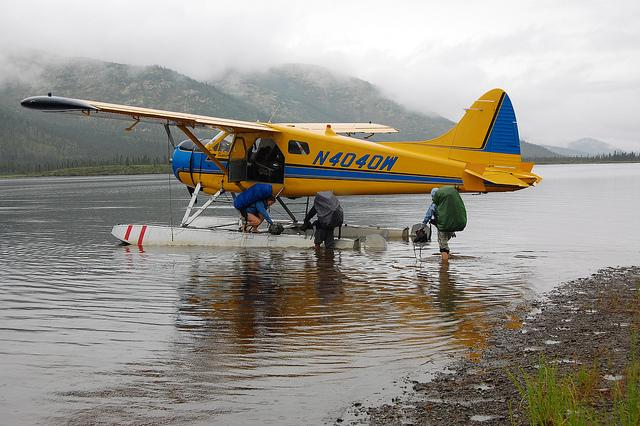What type of plane is being boarded? Please explain your reasoning. pontoon. The type of cessna plane being boarded is called a pontoon with skis. 